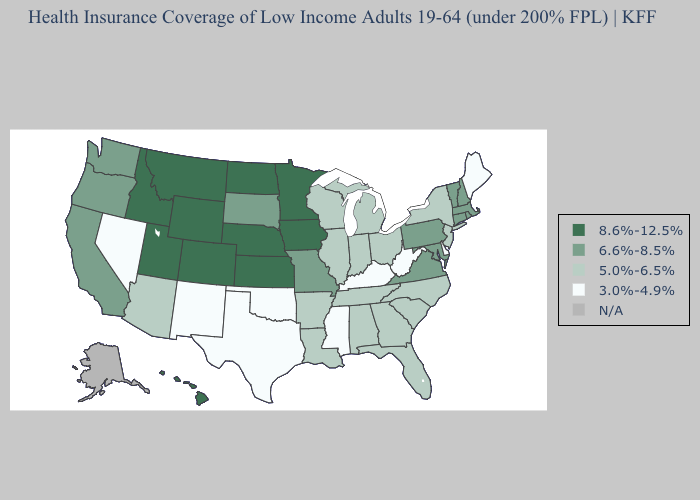How many symbols are there in the legend?
Concise answer only. 5. Does New Jersey have the highest value in the Northeast?
Write a very short answer. No. Which states hav the highest value in the West?
Quick response, please. Colorado, Hawaii, Idaho, Montana, Utah, Wyoming. Among the states that border Colorado , does New Mexico have the highest value?
Answer briefly. No. Among the states that border Montana , does Wyoming have the highest value?
Give a very brief answer. Yes. What is the value of Massachusetts?
Write a very short answer. 6.6%-8.5%. What is the highest value in the South ?
Quick response, please. 6.6%-8.5%. Among the states that border North Dakota , which have the highest value?
Concise answer only. Minnesota, Montana. Name the states that have a value in the range 3.0%-4.9%?
Quick response, please. Delaware, Kentucky, Maine, Mississippi, Nevada, New Mexico, Oklahoma, Texas, West Virginia. Name the states that have a value in the range 8.6%-12.5%?
Be succinct. Colorado, Hawaii, Idaho, Iowa, Kansas, Minnesota, Montana, Nebraska, North Dakota, Utah, Wyoming. Among the states that border Washington , does Oregon have the highest value?
Answer briefly. No. Does Utah have the highest value in the USA?
Concise answer only. Yes. 